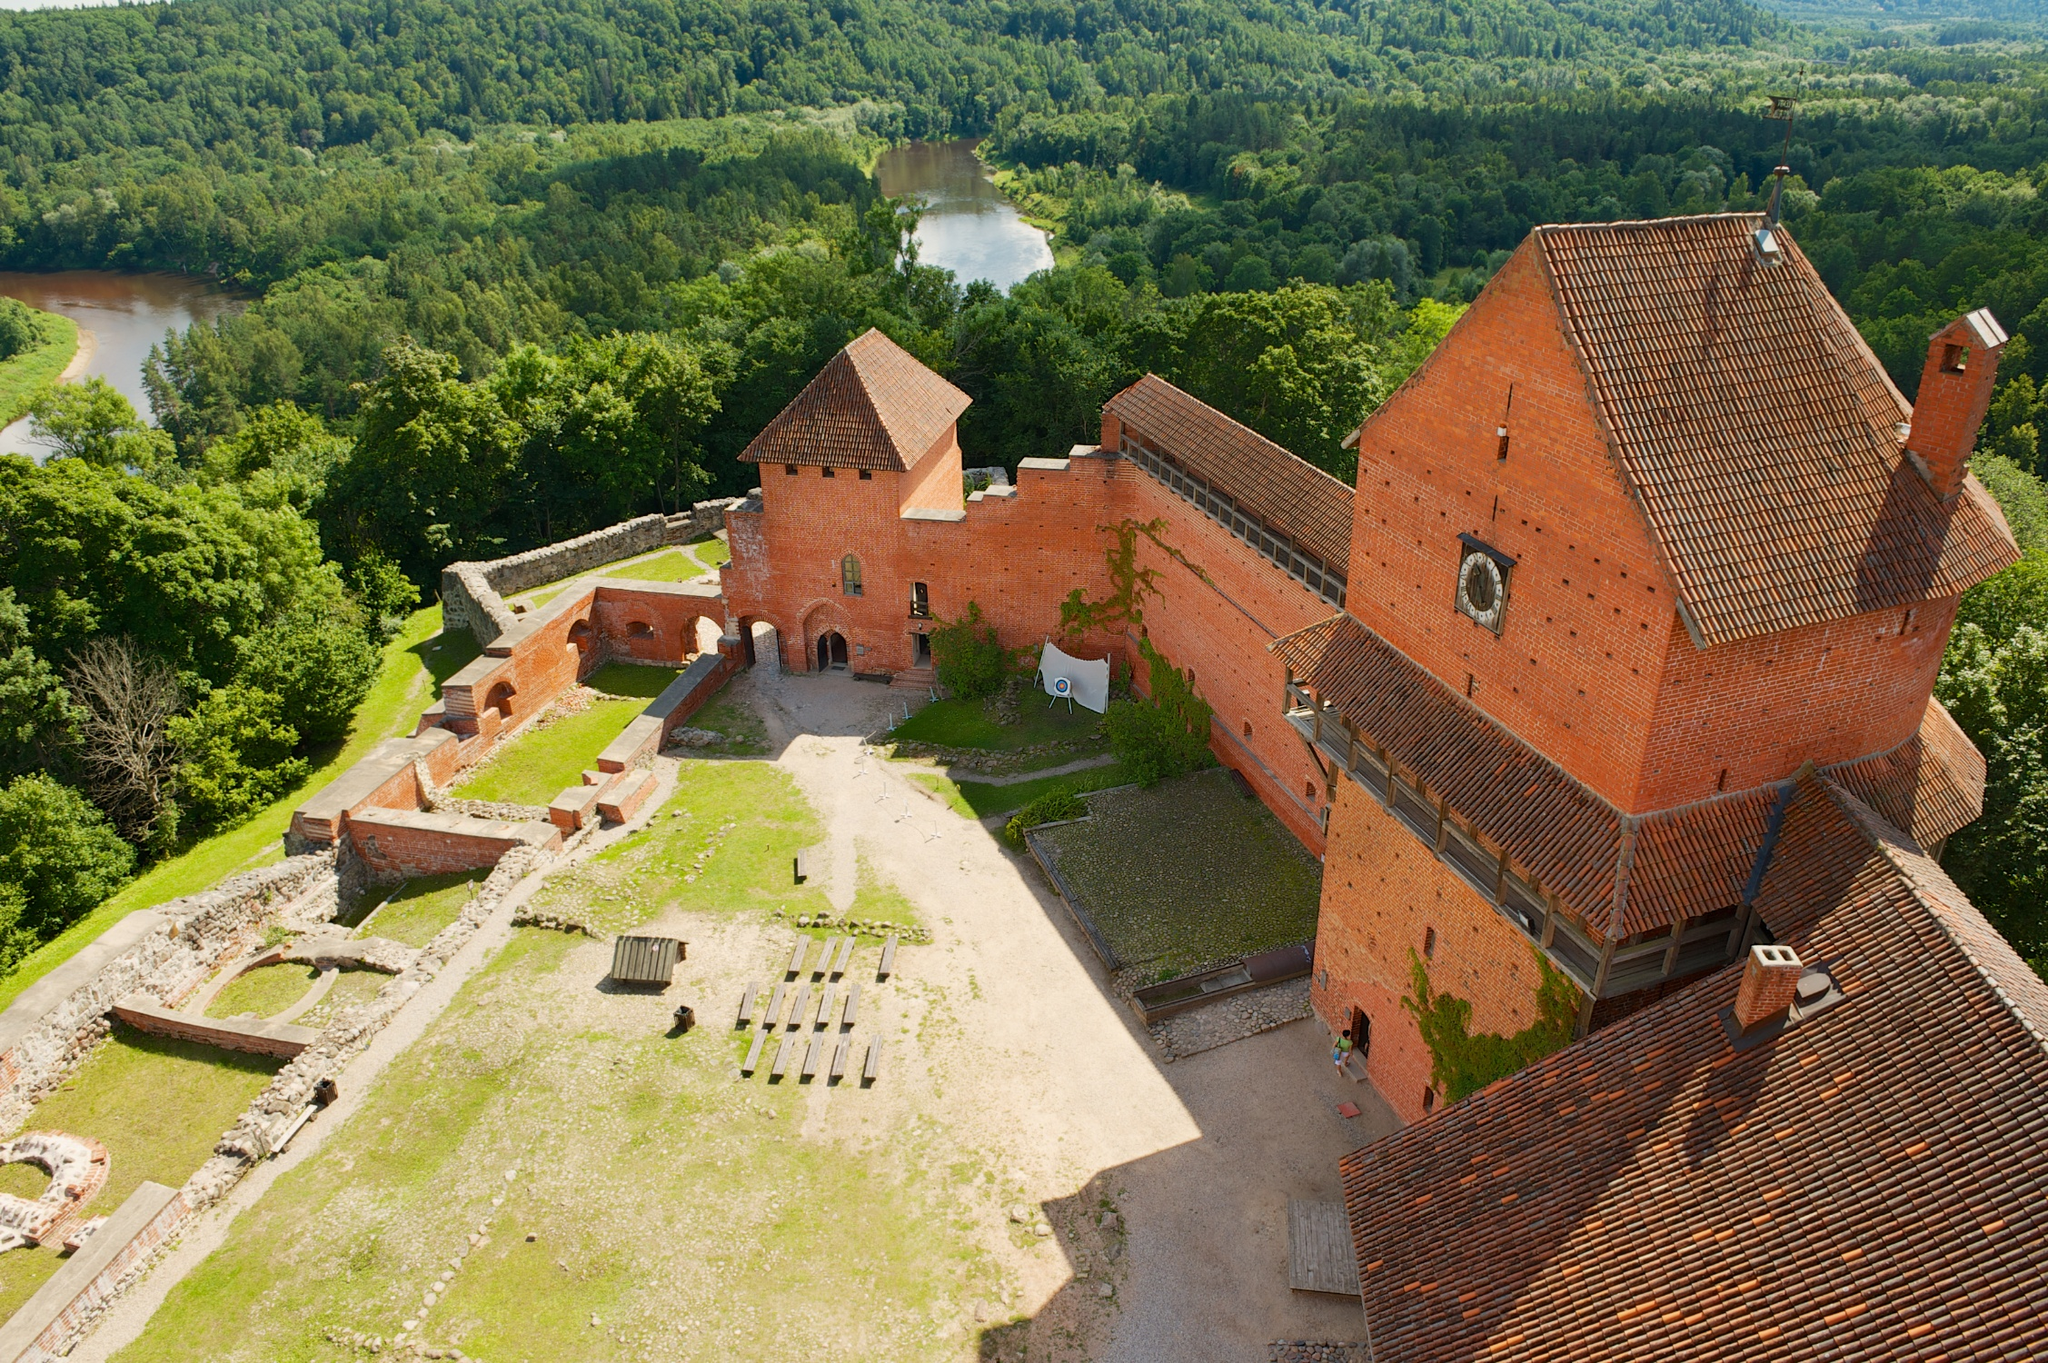Describe a typical day in the life of someone living in this castle during its prime. In the morning, the residents of the castle would awake to the crowing of roosters. Servants scurried about, preparing for the day ahead. The lord of the castle would hold a morning meeting in the great hall, discussing matters of governance and defense. Knights and soldiers trained in the courtyard, sharpening their skills and preparing for any potential threats. In contrast, scholars and scribes worked in the library, transcribing texts and creating illuminated manuscripts.

As the sun climbed higher, the focus shifted to more communal activities. The outdoor areas would be filled with the sounds of children playing and artisans crafting their wares. The castle's kitchen bustled with activity as cooks prepared opulent feasts using fresh produce from the surrounding lands. Lunchtime was a grand affair, with long tables set in the great hall, where everyone gathered to eat and share stories.

The afternoon might involve hunting parties going into the nearby forest, while others tended to the castle gardens or maintained the fortifications. Visitors from nearby regions could bring news, trade goods, and even entertainment in the form of performers and musicians.

By evening, the castle donned a serene atmosphere. The setting sun cast an orange glow over the bricks and the water in the moat reflected the fading daylight. As night fell, torches were lit, and the castle became a haven of quiet reflection and rest. Nobles might engage in leisurely activities such as chess or storytelling by the fire, while guards patrolled the walls, maintaining vigilance until dawn. 